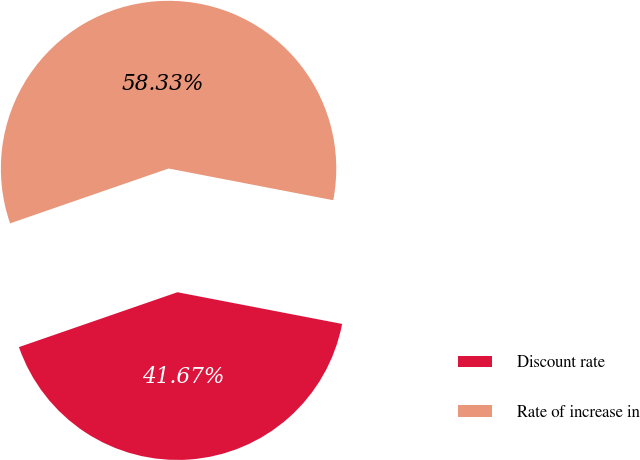Convert chart to OTSL. <chart><loc_0><loc_0><loc_500><loc_500><pie_chart><fcel>Discount rate<fcel>Rate of increase in<nl><fcel>41.67%<fcel>58.33%<nl></chart> 